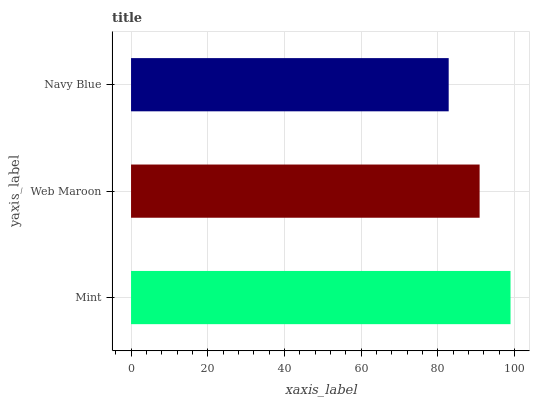Is Navy Blue the minimum?
Answer yes or no. Yes. Is Mint the maximum?
Answer yes or no. Yes. Is Web Maroon the minimum?
Answer yes or no. No. Is Web Maroon the maximum?
Answer yes or no. No. Is Mint greater than Web Maroon?
Answer yes or no. Yes. Is Web Maroon less than Mint?
Answer yes or no. Yes. Is Web Maroon greater than Mint?
Answer yes or no. No. Is Mint less than Web Maroon?
Answer yes or no. No. Is Web Maroon the high median?
Answer yes or no. Yes. Is Web Maroon the low median?
Answer yes or no. Yes. Is Mint the high median?
Answer yes or no. No. Is Navy Blue the low median?
Answer yes or no. No. 